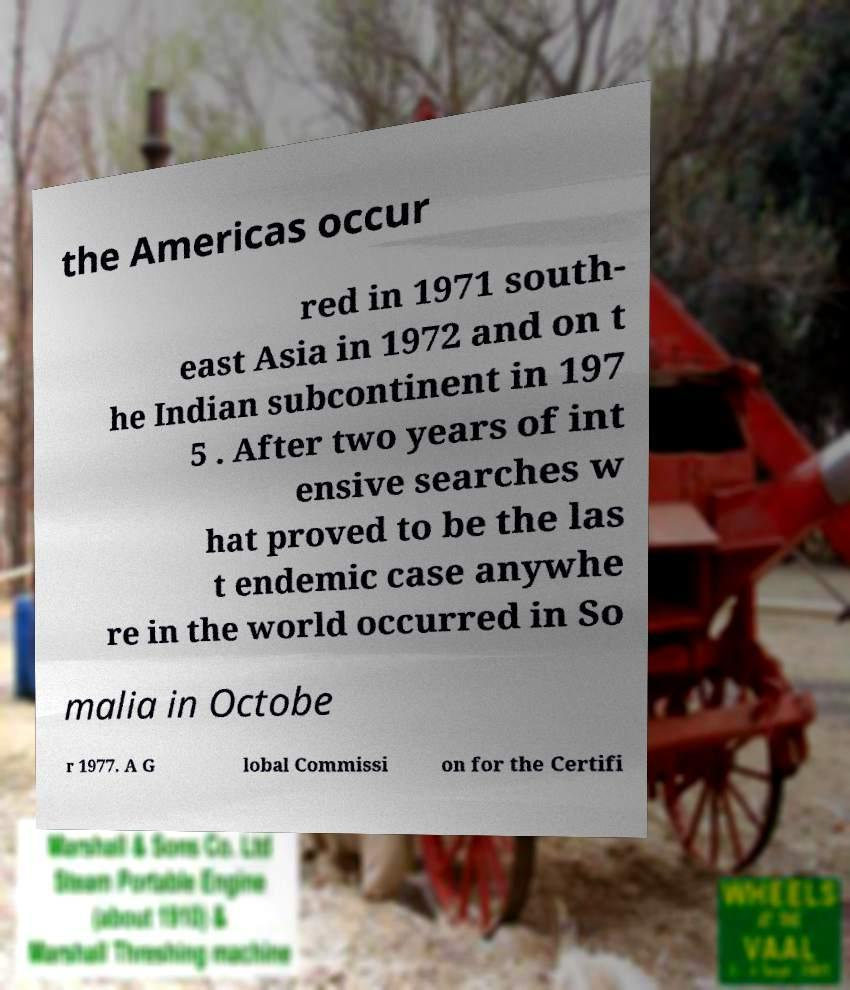Can you read and provide the text displayed in the image?This photo seems to have some interesting text. Can you extract and type it out for me? the Americas occur red in 1971 south- east Asia in 1972 and on t he Indian subcontinent in 197 5 . After two years of int ensive searches w hat proved to be the las t endemic case anywhe re in the world occurred in So malia in Octobe r 1977. A G lobal Commissi on for the Certifi 